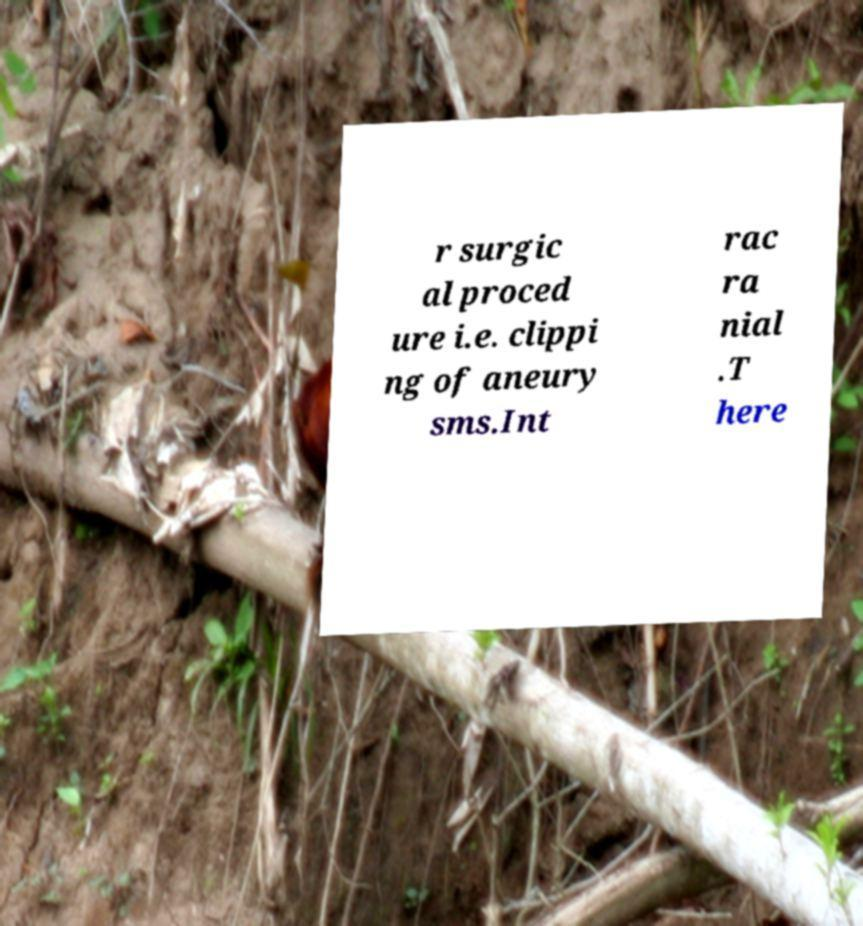Please read and relay the text visible in this image. What does it say? r surgic al proced ure i.e. clippi ng of aneury sms.Int rac ra nial .T here 